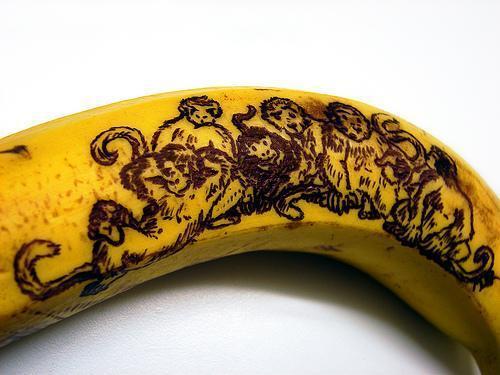How many monkeys are drawn on the banana?
Give a very brief answer. 6. 